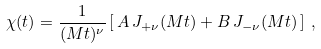<formula> <loc_0><loc_0><loc_500><loc_500>\chi ( t ) = \frac { 1 } { ( M t ) ^ { \nu } } \left [ \, A \, J _ { + \nu } ( M t ) + B \, J _ { - \nu } ( M t ) \, \right ] \, ,</formula> 